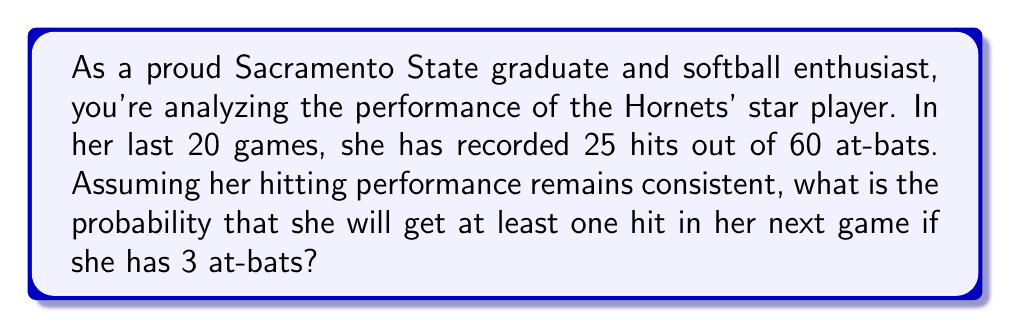Solve this math problem. Let's approach this step-by-step:

1) First, we need to calculate the player's batting average:
   $$ \text{Batting Average} = \frac{\text{Number of Hits}}{\text{Number of At-Bats}} = \frac{25}{60} = \frac{5}{12} \approx 0.417 $$

2) This means the probability of getting a hit in a single at-bat is $\frac{5}{12}$, and the probability of not getting a hit is $1 - \frac{5}{12} = \frac{7}{12}$.

3) Now, we need to find the probability of getting at least one hit in 3 at-bats. It's easier to calculate the probability of not getting any hits and then subtract that from 1.

4) The probability of not getting a hit in all 3 at-bats is:
   $$ P(\text{no hits}) = \left(\frac{7}{12}\right)^3 = \frac{343}{1728} $$

5) Therefore, the probability of getting at least one hit is:
   $$ P(\text{at least one hit}) = 1 - P(\text{no hits}) = 1 - \frac{343}{1728} = \frac{1385}{1728} \approx 0.8015 $$
Answer: The probability that the Sacramento State star player will get at least one hit in her next game with 3 at-bats is $\frac{1385}{1728}$ or approximately 0.8015 or 80.15%. 